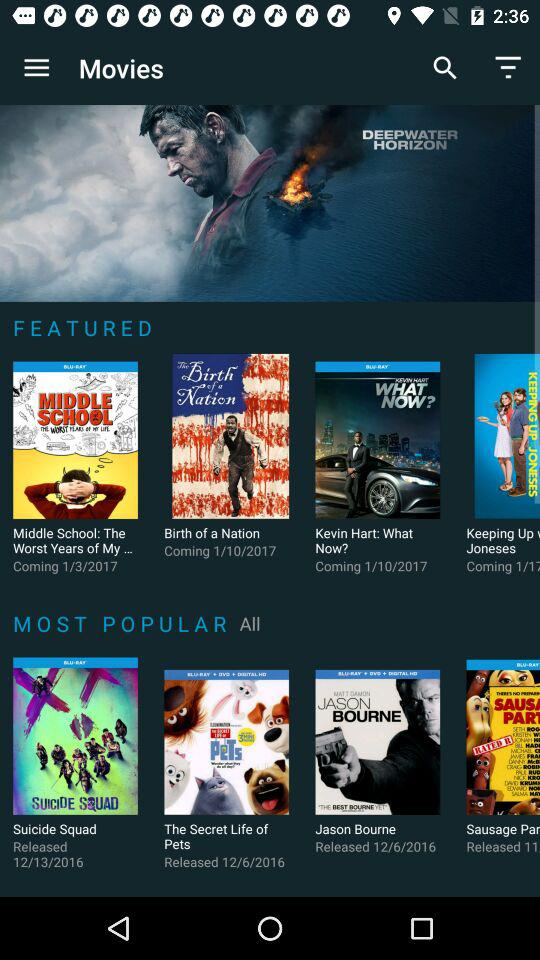How many movies are in the Most Popular section?
Answer the question using a single word or phrase. 4 